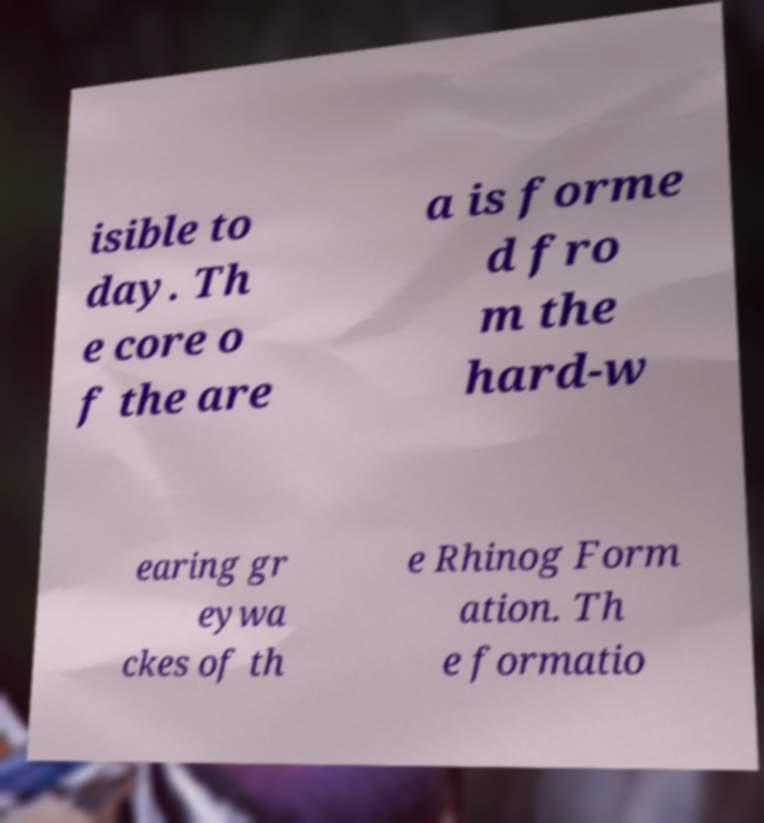For documentation purposes, I need the text within this image transcribed. Could you provide that? isible to day. Th e core o f the are a is forme d fro m the hard-w earing gr eywa ckes of th e Rhinog Form ation. Th e formatio 